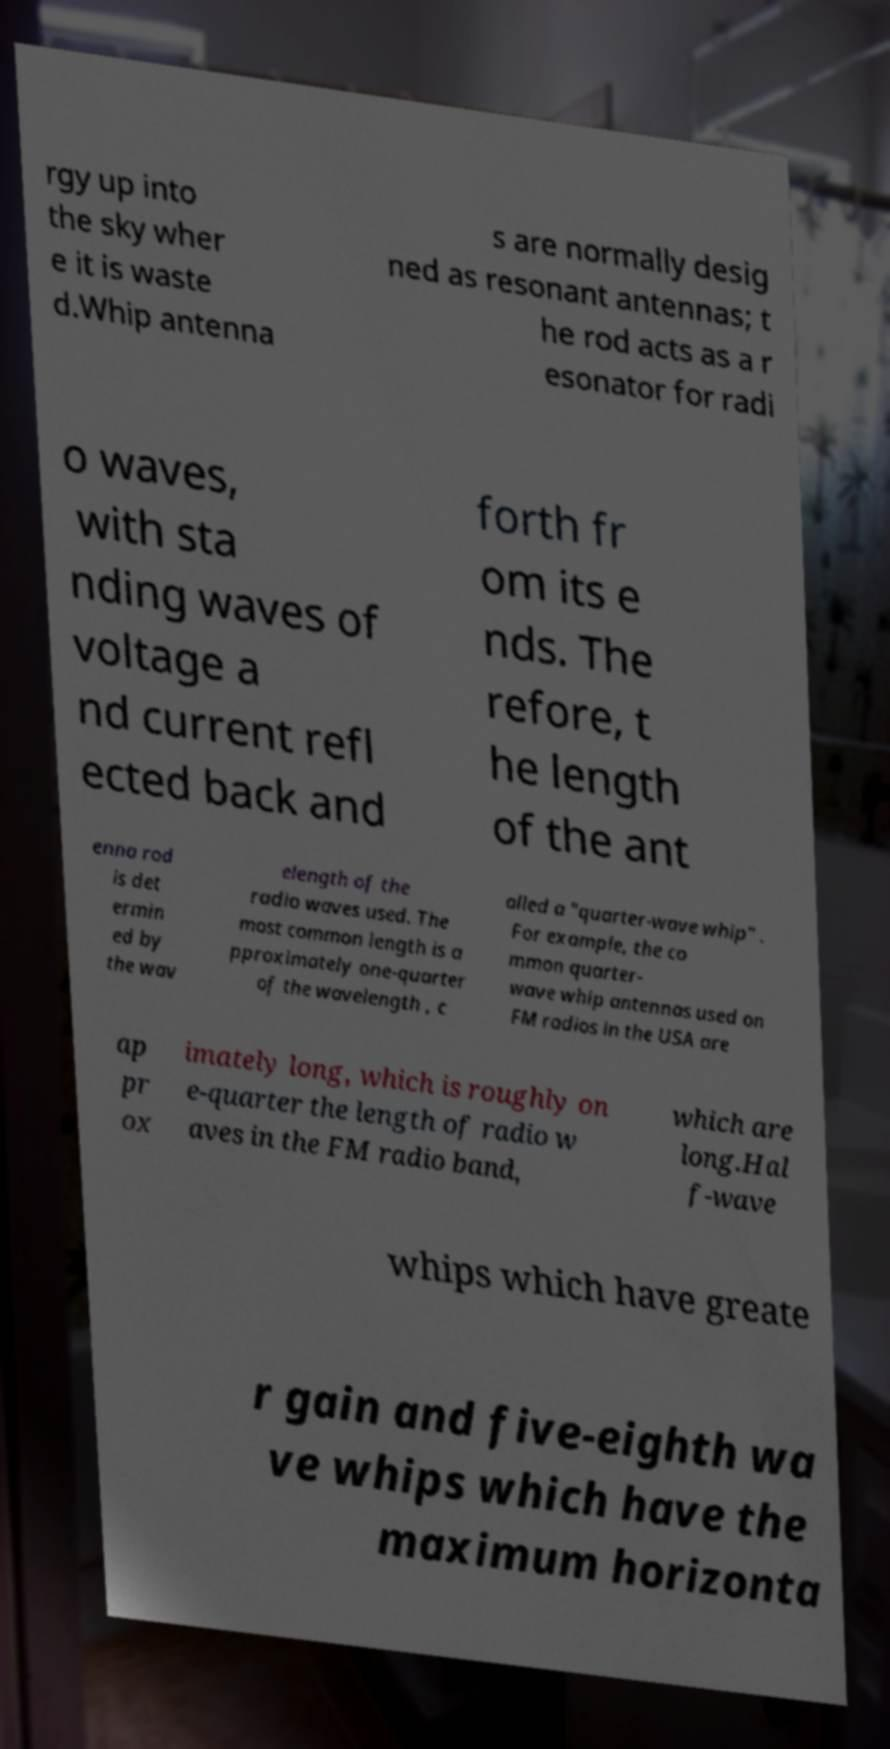What messages or text are displayed in this image? I need them in a readable, typed format. rgy up into the sky wher e it is waste d.Whip antenna s are normally desig ned as resonant antennas; t he rod acts as a r esonator for radi o waves, with sta nding waves of voltage a nd current refl ected back and forth fr om its e nds. The refore, t he length of the ant enna rod is det ermin ed by the wav elength of the radio waves used. The most common length is a pproximately one-quarter of the wavelength , c alled a "quarter-wave whip" . For example, the co mmon quarter- wave whip antennas used on FM radios in the USA are ap pr ox imately long, which is roughly on e-quarter the length of radio w aves in the FM radio band, which are long.Hal f-wave whips which have greate r gain and five-eighth wa ve whips which have the maximum horizonta 